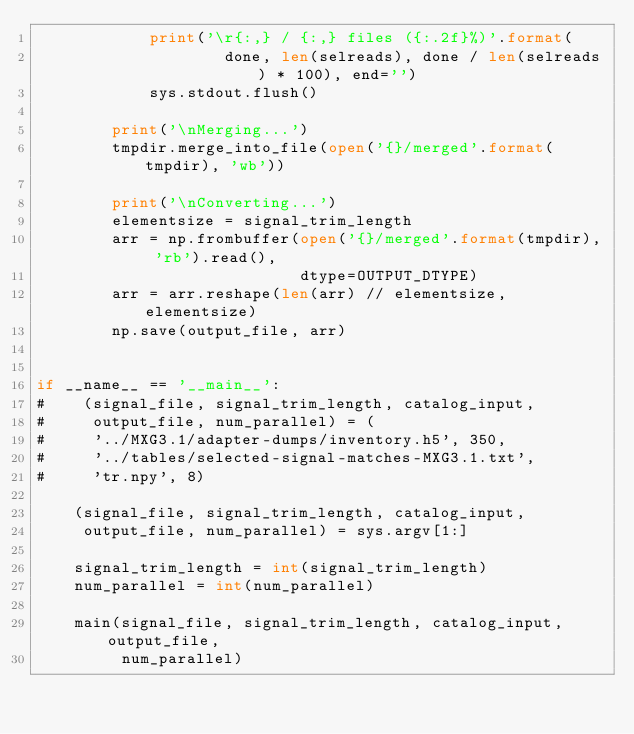Convert code to text. <code><loc_0><loc_0><loc_500><loc_500><_Python_>            print('\r{:,} / {:,} files ({:.2f}%)'.format(
                    done, len(selreads), done / len(selreads) * 100), end='')
            sys.stdout.flush()

        print('\nMerging...')
        tmpdir.merge_into_file(open('{}/merged'.format(tmpdir), 'wb'))

        print('\nConverting...')
        elementsize = signal_trim_length
        arr = np.frombuffer(open('{}/merged'.format(tmpdir), 'rb').read(),
                            dtype=OUTPUT_DTYPE)
        arr = arr.reshape(len(arr) // elementsize, elementsize)
        np.save(output_file, arr)


if __name__ == '__main__':
#    (signal_file, signal_trim_length, catalog_input,
#     output_file, num_parallel) = (
#     '../MXG3.1/adapter-dumps/inventory.h5', 350,
#     '../tables/selected-signal-matches-MXG3.1.txt',
#     'tr.npy', 8)

    (signal_file, signal_trim_length, catalog_input,
     output_file, num_parallel) = sys.argv[1:]

    signal_trim_length = int(signal_trim_length)
    num_parallel = int(num_parallel)

    main(signal_file, signal_trim_length, catalog_input, output_file,
         num_parallel)

</code> 